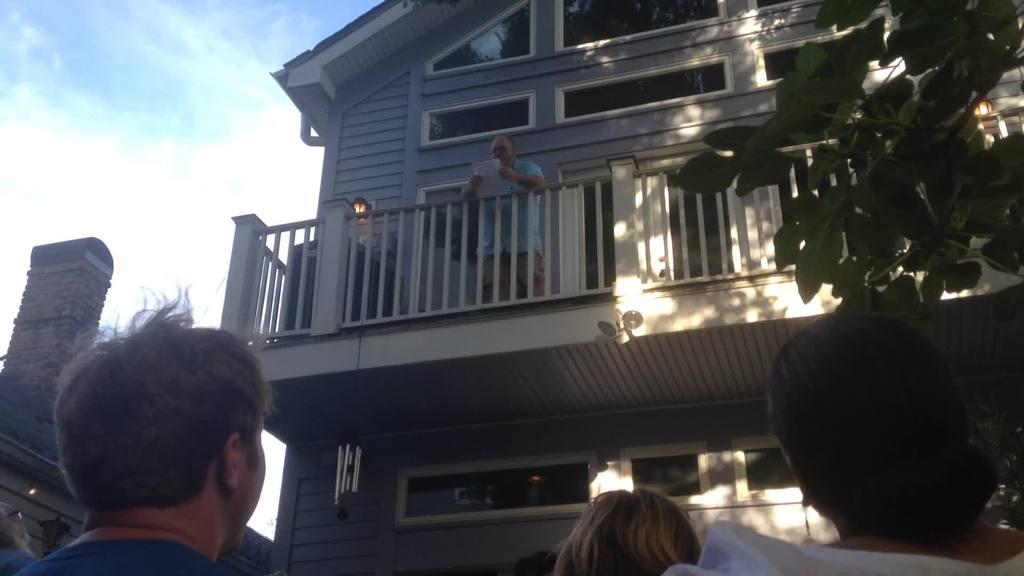What type of structures can be seen in the image? There are houses in the image. Can you describe the man's location in the image? The man is standing in a balcony. Are there any other people visible in the image? Yes, there are people visible in the image. What can be seen on the left side of the image? The sky is visible on the left side of the image. What is present on the right side of the image? A tree is present on the right side of the image. What type of brass instrument is the man playing in the image? There is no brass instrument present in the image; the man is standing in a balcony. How many tomatoes are visible on the tree in the image? There are no tomatoes present in the image; there is a tree on the right side, but it does not have any tomatoes. 